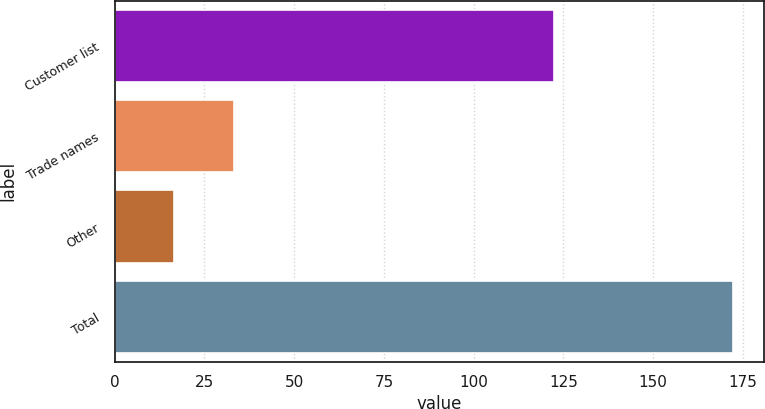<chart> <loc_0><loc_0><loc_500><loc_500><bar_chart><fcel>Customer list<fcel>Trade names<fcel>Other<fcel>Total<nl><fcel>122.5<fcel>33.2<fcel>16.5<fcel>172.2<nl></chart> 